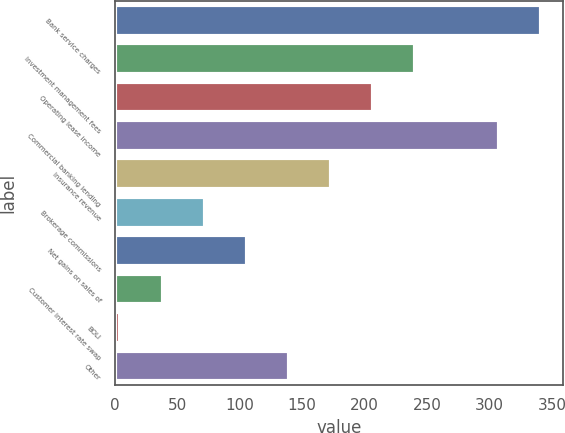<chart> <loc_0><loc_0><loc_500><loc_500><bar_chart><fcel>Bank service charges<fcel>Investment management fees<fcel>Operating lease income<fcel>Commercial banking lending<fcel>Insurance revenue<fcel>Brokerage commissions<fcel>Net gains on sales of<fcel>Customer interest rate swap<fcel>BOLI<fcel>Other<nl><fcel>341.7<fcel>240.54<fcel>206.82<fcel>307.98<fcel>173.1<fcel>71.94<fcel>105.66<fcel>38.22<fcel>4.5<fcel>139.38<nl></chart> 